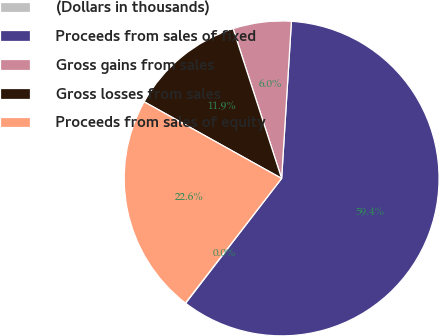Convert chart to OTSL. <chart><loc_0><loc_0><loc_500><loc_500><pie_chart><fcel>(Dollars in thousands)<fcel>Proceeds from sales of fixed<fcel>Gross gains from sales<fcel>Gross losses from sales<fcel>Proceeds from sales of equity<nl><fcel>0.04%<fcel>59.44%<fcel>5.98%<fcel>11.92%<fcel>22.63%<nl></chart> 